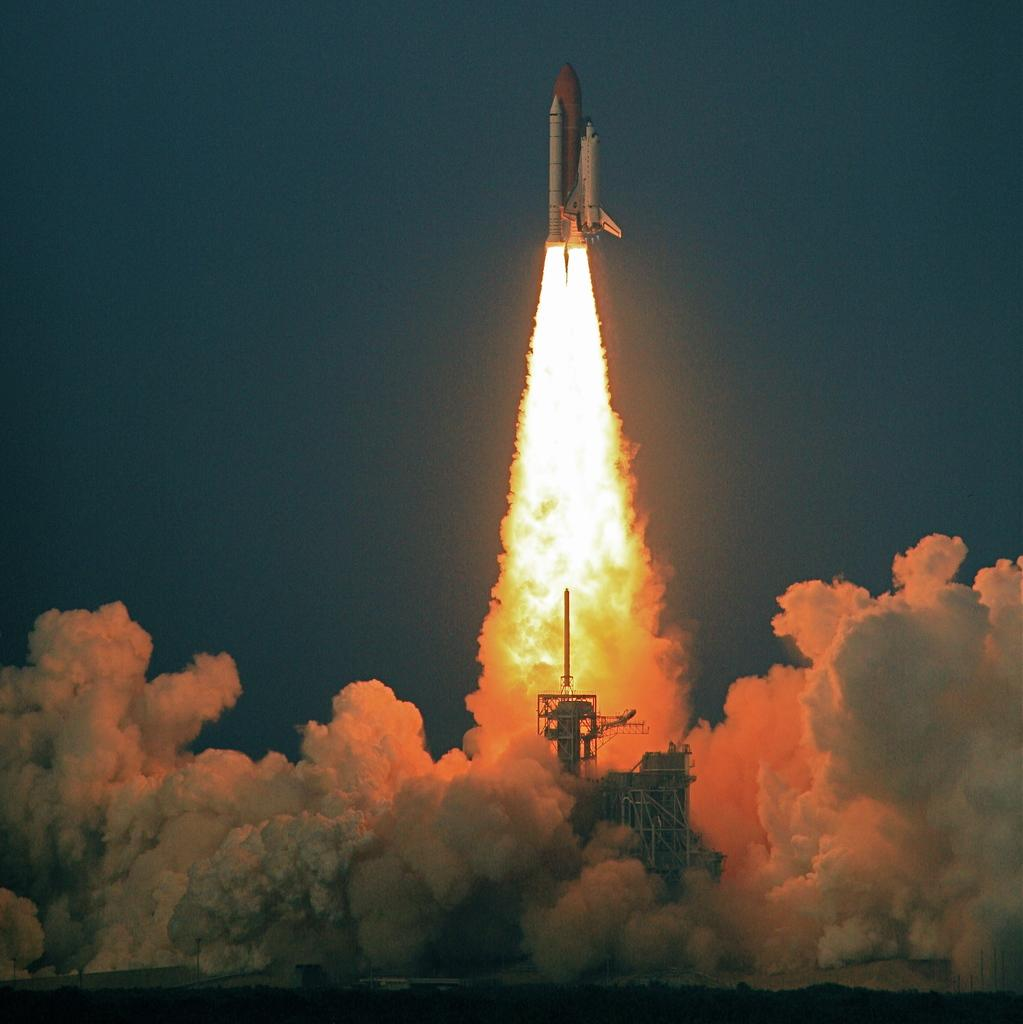What is the main subject of the image? The main subject of the image is a rocket. What is located near the rocket in the image? There is a launchpad in the image. What can be seen coming from the rocket in the image? Smoke and fire are visible in the image. What type of joke is being told by the rocket in the image? There is no indication in the image that a joke is being told, as rockets do not have the ability to tell jokes. 